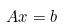Convert formula to latex. <formula><loc_0><loc_0><loc_500><loc_500>A x & = b</formula> 